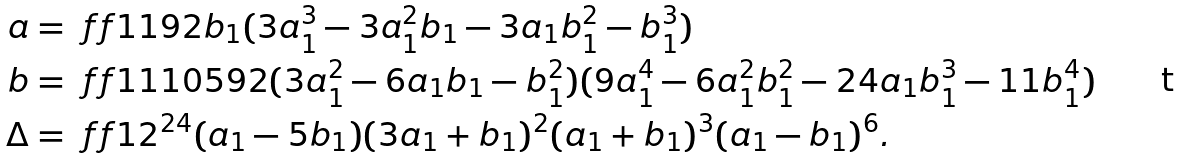<formula> <loc_0><loc_0><loc_500><loc_500>a & = \ f f 1 { 1 9 2 } b _ { 1 } ( 3 a _ { 1 } ^ { 3 } - 3 a _ { 1 } ^ { 2 } b _ { 1 } - 3 a _ { 1 } b _ { 1 } ^ { 2 } - b _ { 1 } ^ { 3 } ) \\ b & = \ f f 1 { 1 1 0 5 9 2 } ( 3 a _ { 1 } ^ { 2 } - 6 a _ { 1 } b _ { 1 } - b _ { 1 } ^ { 2 } ) ( 9 a _ { 1 } ^ { 4 } - 6 a _ { 1 } ^ { 2 } b _ { 1 } ^ { 2 } - 2 4 a _ { 1 } b _ { 1 } ^ { 3 } - 1 1 b _ { 1 } ^ { 4 } ) \\ \Delta & = \ f f 1 { 2 ^ { 2 4 } } ( a _ { 1 } - 5 b _ { 1 } ) ( 3 a _ { 1 } + b _ { 1 } ) ^ { 2 } ( a _ { 1 } + b _ { 1 } ) ^ { 3 } ( a _ { 1 } - b _ { 1 } ) ^ { 6 } .</formula> 